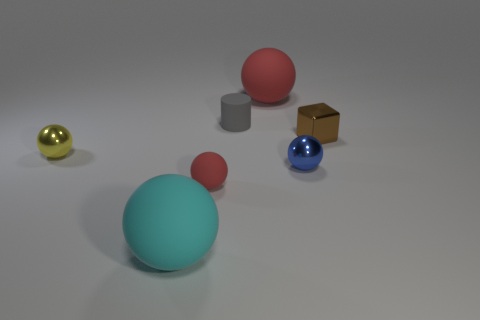Subtract all big rubber balls. How many balls are left? 3 Subtract all cyan balls. How many balls are left? 4 Subtract all red balls. Subtract all brown cubes. How many balls are left? 3 Subtract all purple cubes. How many red balls are left? 2 Subtract all yellow things. Subtract all matte spheres. How many objects are left? 3 Add 4 small red rubber spheres. How many small red rubber spheres are left? 5 Add 2 metallic things. How many metallic things exist? 5 Add 1 big rubber things. How many objects exist? 8 Subtract 1 gray cylinders. How many objects are left? 6 Subtract all spheres. How many objects are left? 2 